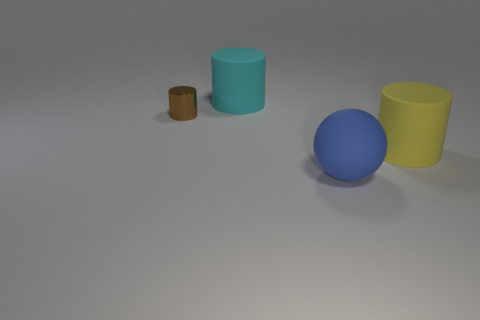Is there anything else that has the same material as the tiny brown cylinder?
Offer a very short reply. No. The other small thing that is the same shape as the cyan matte thing is what color?
Offer a very short reply. Brown. Is there any other thing that has the same shape as the cyan thing?
Your response must be concise. Yes. Is there a yellow rubber cylinder on the right side of the large cylinder in front of the big object behind the yellow matte cylinder?
Offer a terse response. No. How many things are the same material as the big blue ball?
Give a very brief answer. 2. There is a object that is in front of the yellow cylinder; is its size the same as the object on the left side of the cyan rubber cylinder?
Provide a succinct answer. No. There is a large rubber cylinder that is on the left side of the cylinder that is on the right side of the large matte object that is on the left side of the large blue rubber ball; what color is it?
Your answer should be compact. Cyan. Is there a large object of the same shape as the small shiny object?
Provide a succinct answer. Yes. Are there an equal number of matte things that are behind the large matte sphere and brown objects on the left side of the brown cylinder?
Ensure brevity in your answer.  No. There is a big object in front of the yellow matte cylinder; is it the same shape as the tiny brown metallic thing?
Keep it short and to the point. No. 